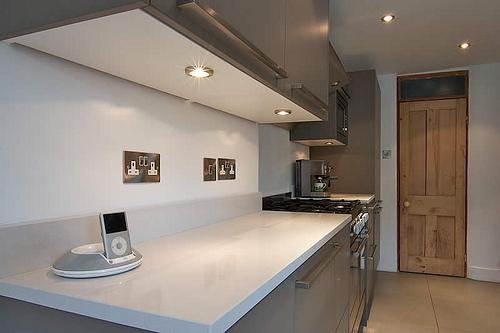Question: what is the iPod sitting in?
Choices:
A. In a car seat.
B. In a drawer.
C. In a cup.
D. The iPod Dock.
Answer with the letter. Answer: D Question: what type of material is the door composed of?
Choices:
A. Stone.
B. Plastic.
C. Metal.
D. Wood.
Answer with the letter. Answer: D Question: how many lights are in the ceiling?
Choices:
A. 3.
B. 4.
C. 5.
D. 2.
Answer with the letter. Answer: D 